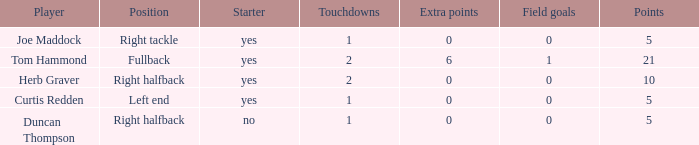Name the most touchdowns for field goals being 1 2.0. 